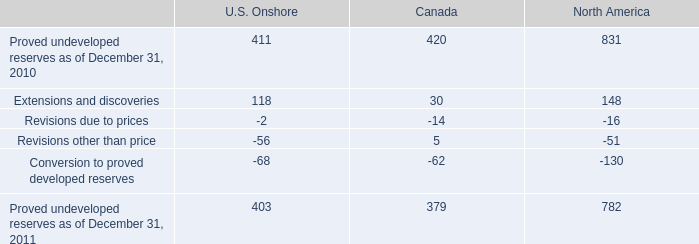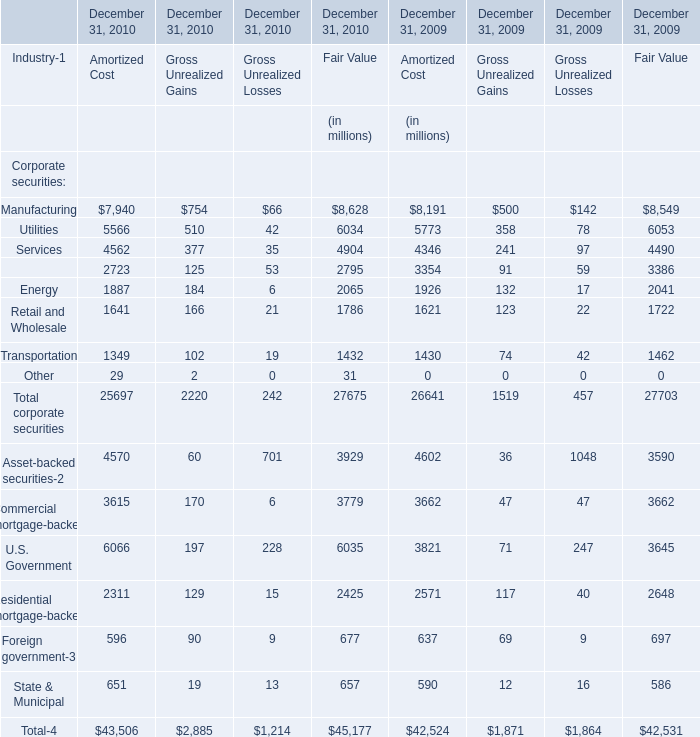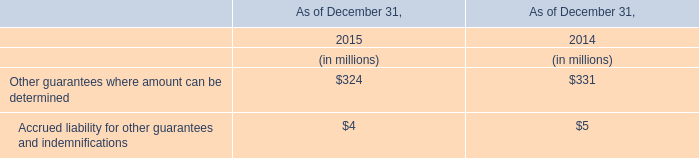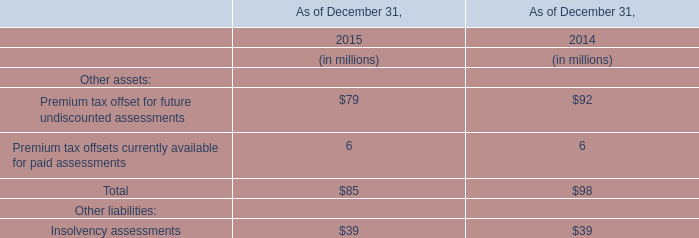what was the percentage change in total proved undeveloped reserves for canada from 2010 to 2011? 
Computations: ((379 - 420) / 420)
Answer: -0.09762. 